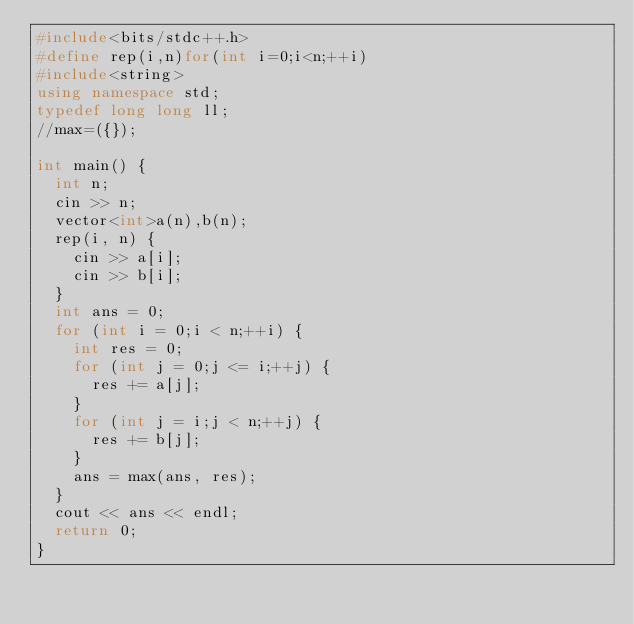<code> <loc_0><loc_0><loc_500><loc_500><_C++_>#include<bits/stdc++.h>
#define rep(i,n)for(int i=0;i<n;++i)
#include<string>
using namespace std;
typedef long long ll;
//max=({});

int main() {
	int n;
	cin >> n;
	vector<int>a(n),b(n);
	rep(i, n) {
		cin >> a[i];
		cin >> b[i];
	}
	int ans = 0;
	for (int i = 0;i < n;++i) {
		int res = 0;
		for (int j = 0;j <= i;++j) {
			res += a[j];
		}
		for (int j = i;j < n;++j) {
			res += b[j];
		}
		ans = max(ans, res);
	}
	cout << ans << endl;
	return 0;
}
</code> 